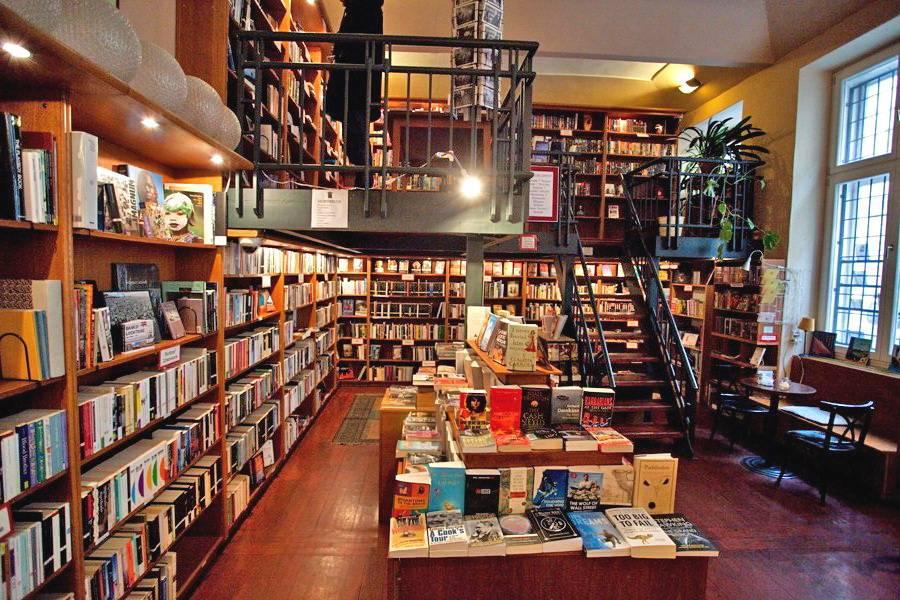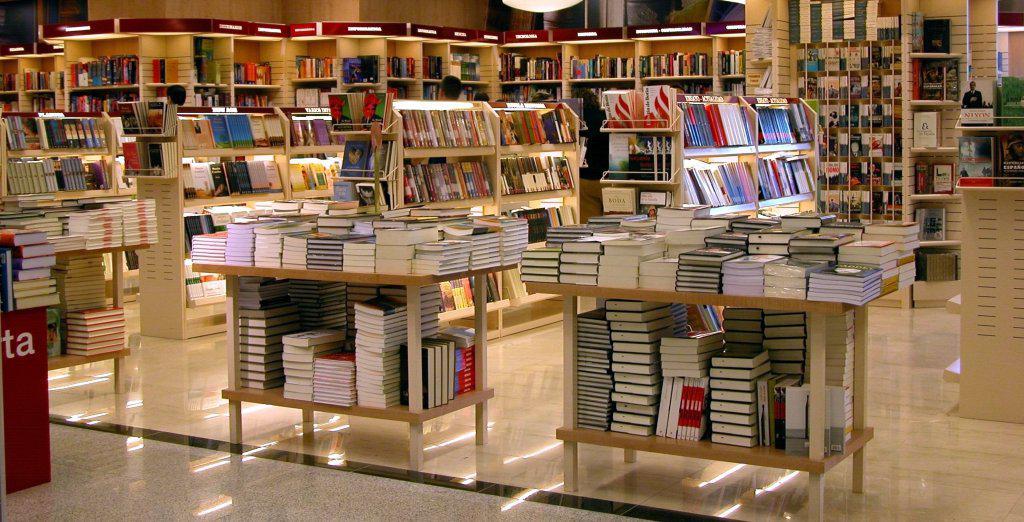The first image is the image on the left, the second image is the image on the right. For the images shown, is this caption "At least one image is inside the store, and there is a window you can see out of." true? Answer yes or no. Yes. 